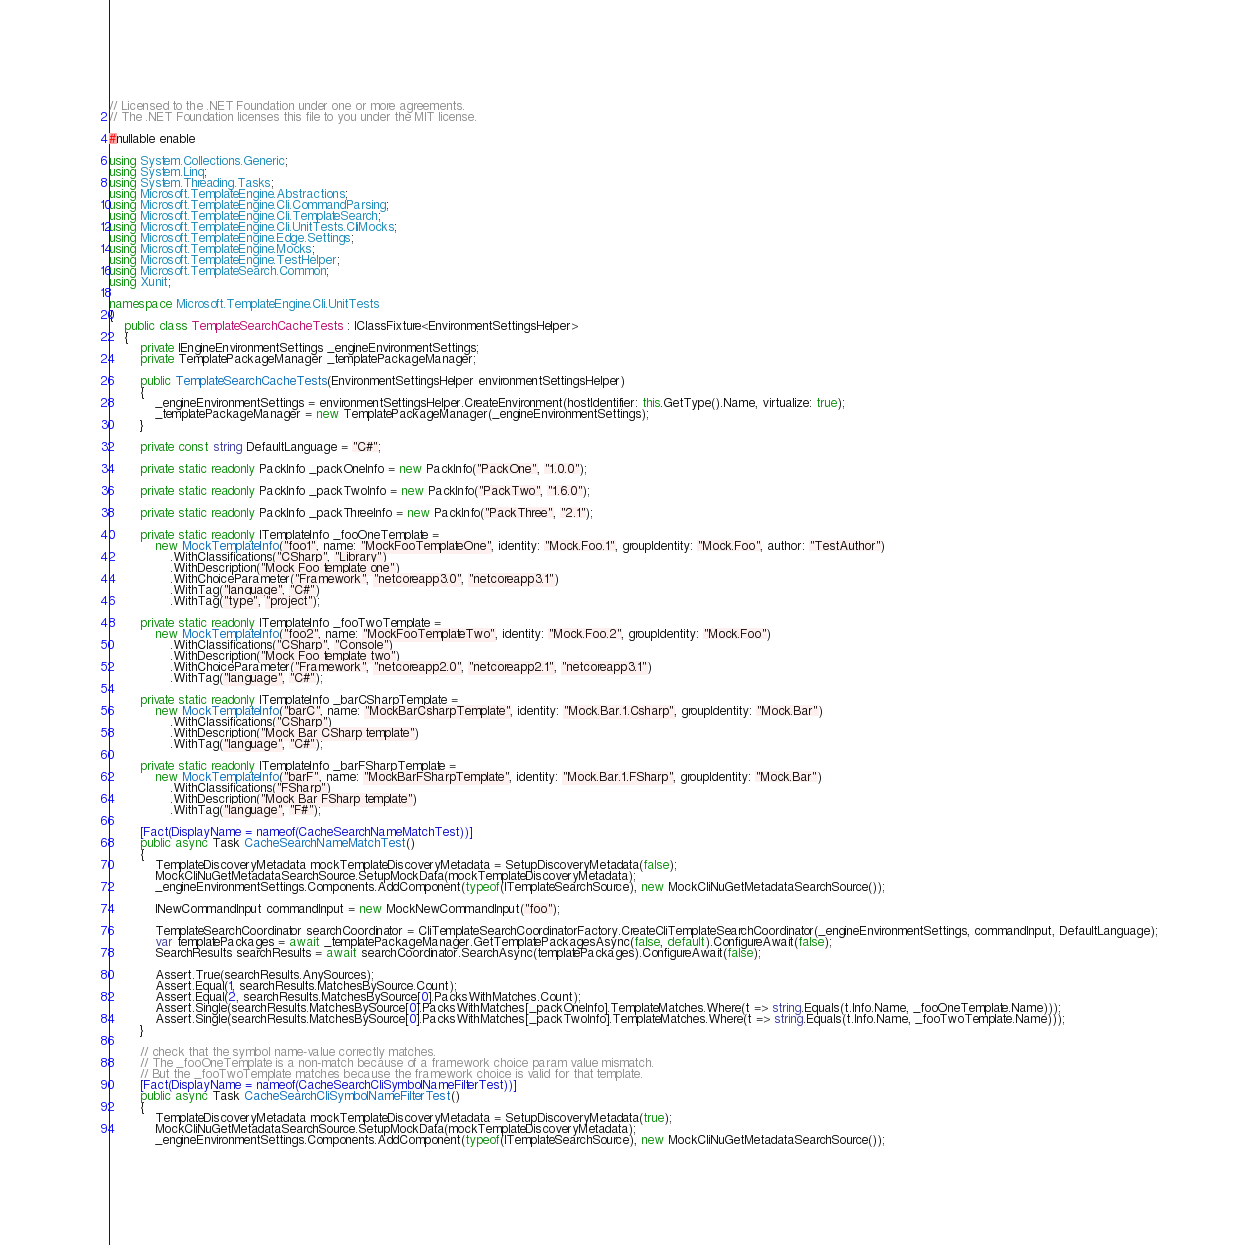<code> <loc_0><loc_0><loc_500><loc_500><_C#_>// Licensed to the .NET Foundation under one or more agreements.
// The .NET Foundation licenses this file to you under the MIT license.

#nullable enable

using System.Collections.Generic;
using System.Linq;
using System.Threading.Tasks;
using Microsoft.TemplateEngine.Abstractions;
using Microsoft.TemplateEngine.Cli.CommandParsing;
using Microsoft.TemplateEngine.Cli.TemplateSearch;
using Microsoft.TemplateEngine.Cli.UnitTests.CliMocks;
using Microsoft.TemplateEngine.Edge.Settings;
using Microsoft.TemplateEngine.Mocks;
using Microsoft.TemplateEngine.TestHelper;
using Microsoft.TemplateSearch.Common;
using Xunit;

namespace Microsoft.TemplateEngine.Cli.UnitTests
{
    public class TemplateSearchCacheTests : IClassFixture<EnvironmentSettingsHelper>
    {
        private IEngineEnvironmentSettings _engineEnvironmentSettings;
        private TemplatePackageManager _templatePackageManager;

        public TemplateSearchCacheTests(EnvironmentSettingsHelper environmentSettingsHelper)
        {
            _engineEnvironmentSettings = environmentSettingsHelper.CreateEnvironment(hostIdentifier: this.GetType().Name, virtualize: true);
            _templatePackageManager = new TemplatePackageManager(_engineEnvironmentSettings);
        }

        private const string DefaultLanguage = "C#";

        private static readonly PackInfo _packOneInfo = new PackInfo("PackOne", "1.0.0");

        private static readonly PackInfo _packTwoInfo = new PackInfo("PackTwo", "1.6.0");

        private static readonly PackInfo _packThreeInfo = new PackInfo("PackThree", "2.1");

        private static readonly ITemplateInfo _fooOneTemplate =
            new MockTemplateInfo("foo1", name: "MockFooTemplateOne", identity: "Mock.Foo.1", groupIdentity: "Mock.Foo", author: "TestAuthor")
                .WithClassifications("CSharp", "Library")
                .WithDescription("Mock Foo template one")
                .WithChoiceParameter("Framework", "netcoreapp3.0", "netcoreapp3.1")
                .WithTag("language", "C#")
                .WithTag("type", "project");

        private static readonly ITemplateInfo _fooTwoTemplate =
            new MockTemplateInfo("foo2", name: "MockFooTemplateTwo", identity: "Mock.Foo.2", groupIdentity: "Mock.Foo")
                .WithClassifications("CSharp", "Console")
                .WithDescription("Mock Foo template two")
                .WithChoiceParameter("Framework", "netcoreapp2.0", "netcoreapp2.1", "netcoreapp3.1")
                .WithTag("language", "C#");

        private static readonly ITemplateInfo _barCSharpTemplate =
            new MockTemplateInfo("barC", name: "MockBarCsharpTemplate", identity: "Mock.Bar.1.Csharp", groupIdentity: "Mock.Bar")
                .WithClassifications("CSharp")
                .WithDescription("Mock Bar CSharp template")
                .WithTag("language", "C#");

        private static readonly ITemplateInfo _barFSharpTemplate =
            new MockTemplateInfo("barF", name: "MockBarFSharpTemplate", identity: "Mock.Bar.1.FSharp", groupIdentity: "Mock.Bar")
                .WithClassifications("FSharp")
                .WithDescription("Mock Bar FSharp template")
                .WithTag("language", "F#");

        [Fact(DisplayName = nameof(CacheSearchNameMatchTest))]
        public async Task CacheSearchNameMatchTest()
        {
            TemplateDiscoveryMetadata mockTemplateDiscoveryMetadata = SetupDiscoveryMetadata(false);
            MockCliNuGetMetadataSearchSource.SetupMockData(mockTemplateDiscoveryMetadata);
            _engineEnvironmentSettings.Components.AddComponent(typeof(ITemplateSearchSource), new MockCliNuGetMetadataSearchSource());

            INewCommandInput commandInput = new MockNewCommandInput("foo");

            TemplateSearchCoordinator searchCoordinator = CliTemplateSearchCoordinatorFactory.CreateCliTemplateSearchCoordinator(_engineEnvironmentSettings, commandInput, DefaultLanguage);
            var templatePackages = await _templatePackageManager.GetTemplatePackagesAsync(false, default).ConfigureAwait(false);
            SearchResults searchResults = await searchCoordinator.SearchAsync(templatePackages).ConfigureAwait(false);

            Assert.True(searchResults.AnySources);
            Assert.Equal(1, searchResults.MatchesBySource.Count);
            Assert.Equal(2, searchResults.MatchesBySource[0].PacksWithMatches.Count);
            Assert.Single(searchResults.MatchesBySource[0].PacksWithMatches[_packOneInfo].TemplateMatches.Where(t => string.Equals(t.Info.Name, _fooOneTemplate.Name)));
            Assert.Single(searchResults.MatchesBySource[0].PacksWithMatches[_packTwoInfo].TemplateMatches.Where(t => string.Equals(t.Info.Name, _fooTwoTemplate.Name)));
        }

        // check that the symbol name-value correctly matches.
        // The _fooOneTemplate is a non-match because of a framework choice param value mismatch.
        // But the _fooTwoTemplate matches because the framework choice is valid for that template.
        [Fact(DisplayName = nameof(CacheSearchCliSymbolNameFilterTest))]
        public async Task CacheSearchCliSymbolNameFilterTest()
        {
            TemplateDiscoveryMetadata mockTemplateDiscoveryMetadata = SetupDiscoveryMetadata(true);
            MockCliNuGetMetadataSearchSource.SetupMockData(mockTemplateDiscoveryMetadata);
            _engineEnvironmentSettings.Components.AddComponent(typeof(ITemplateSearchSource), new MockCliNuGetMetadataSearchSource());
</code> 